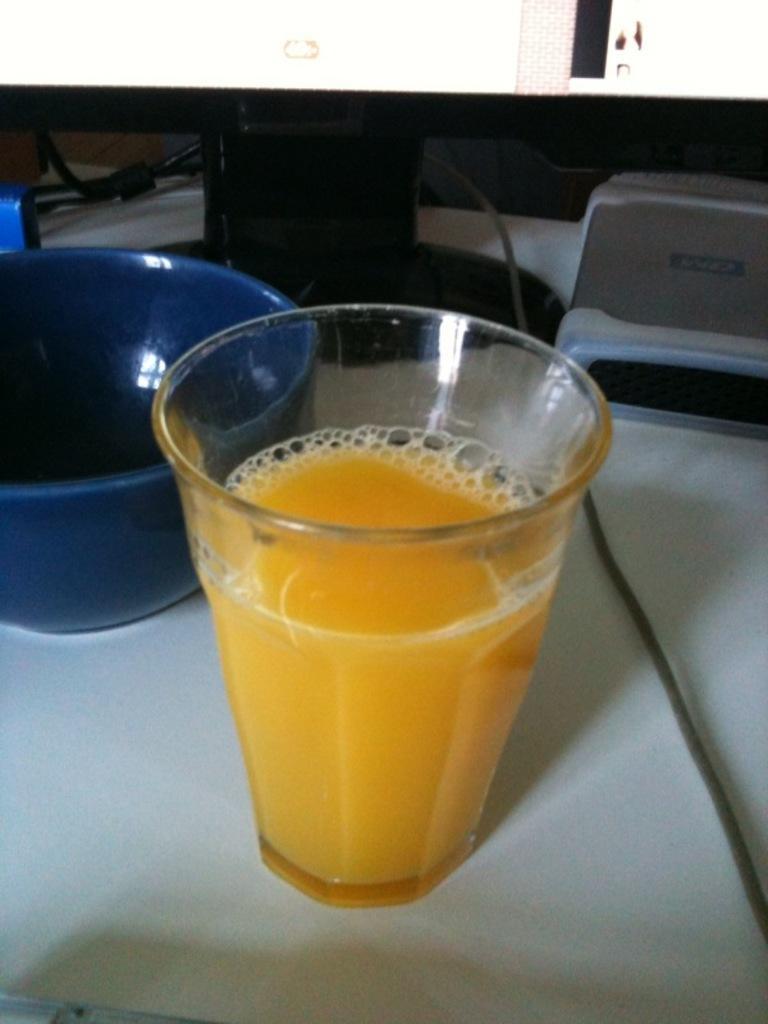Can you describe this image briefly? At the bottom of the image there is a table, on the table there is glass, bowl and screen and there are some wires. 